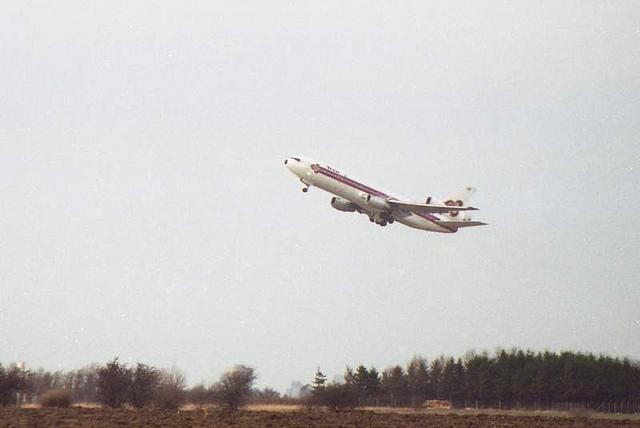What is flying in the sky?
Concise answer only. Plane. Are the wings straight?
Keep it brief. Yes. Is the plane going to land soon?
Answer briefly. No. Is it summer?
Concise answer only. No. Is the sky blue?
Short answer required. No. What is written on the side of the plane?
Short answer required. Nothing. What airlines is this?
Short answer required. American. Is the airplane landing?
Give a very brief answer. No. Are there clouds?
Keep it brief. Yes. 